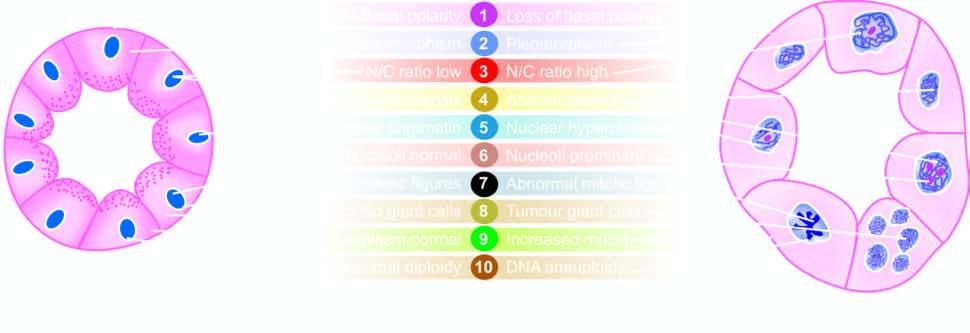re characteristics of cancer in a gland contrasted with the appearance of an acinus?
Answer the question using a single word or phrase. Yes 